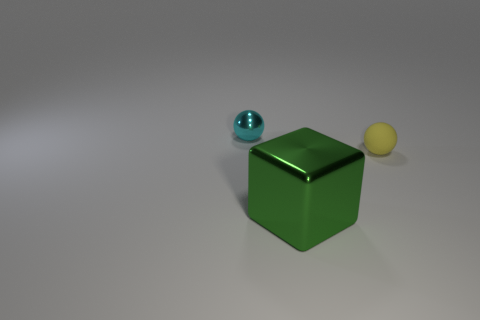Add 1 tiny yellow shiny balls. How many objects exist? 4 Subtract all spheres. How many objects are left? 1 Add 2 large green rubber spheres. How many large green rubber spheres exist? 2 Subtract 0 red cylinders. How many objects are left? 3 Subtract all tiny brown matte cylinders. Subtract all shiny cubes. How many objects are left? 2 Add 1 large objects. How many large objects are left? 2 